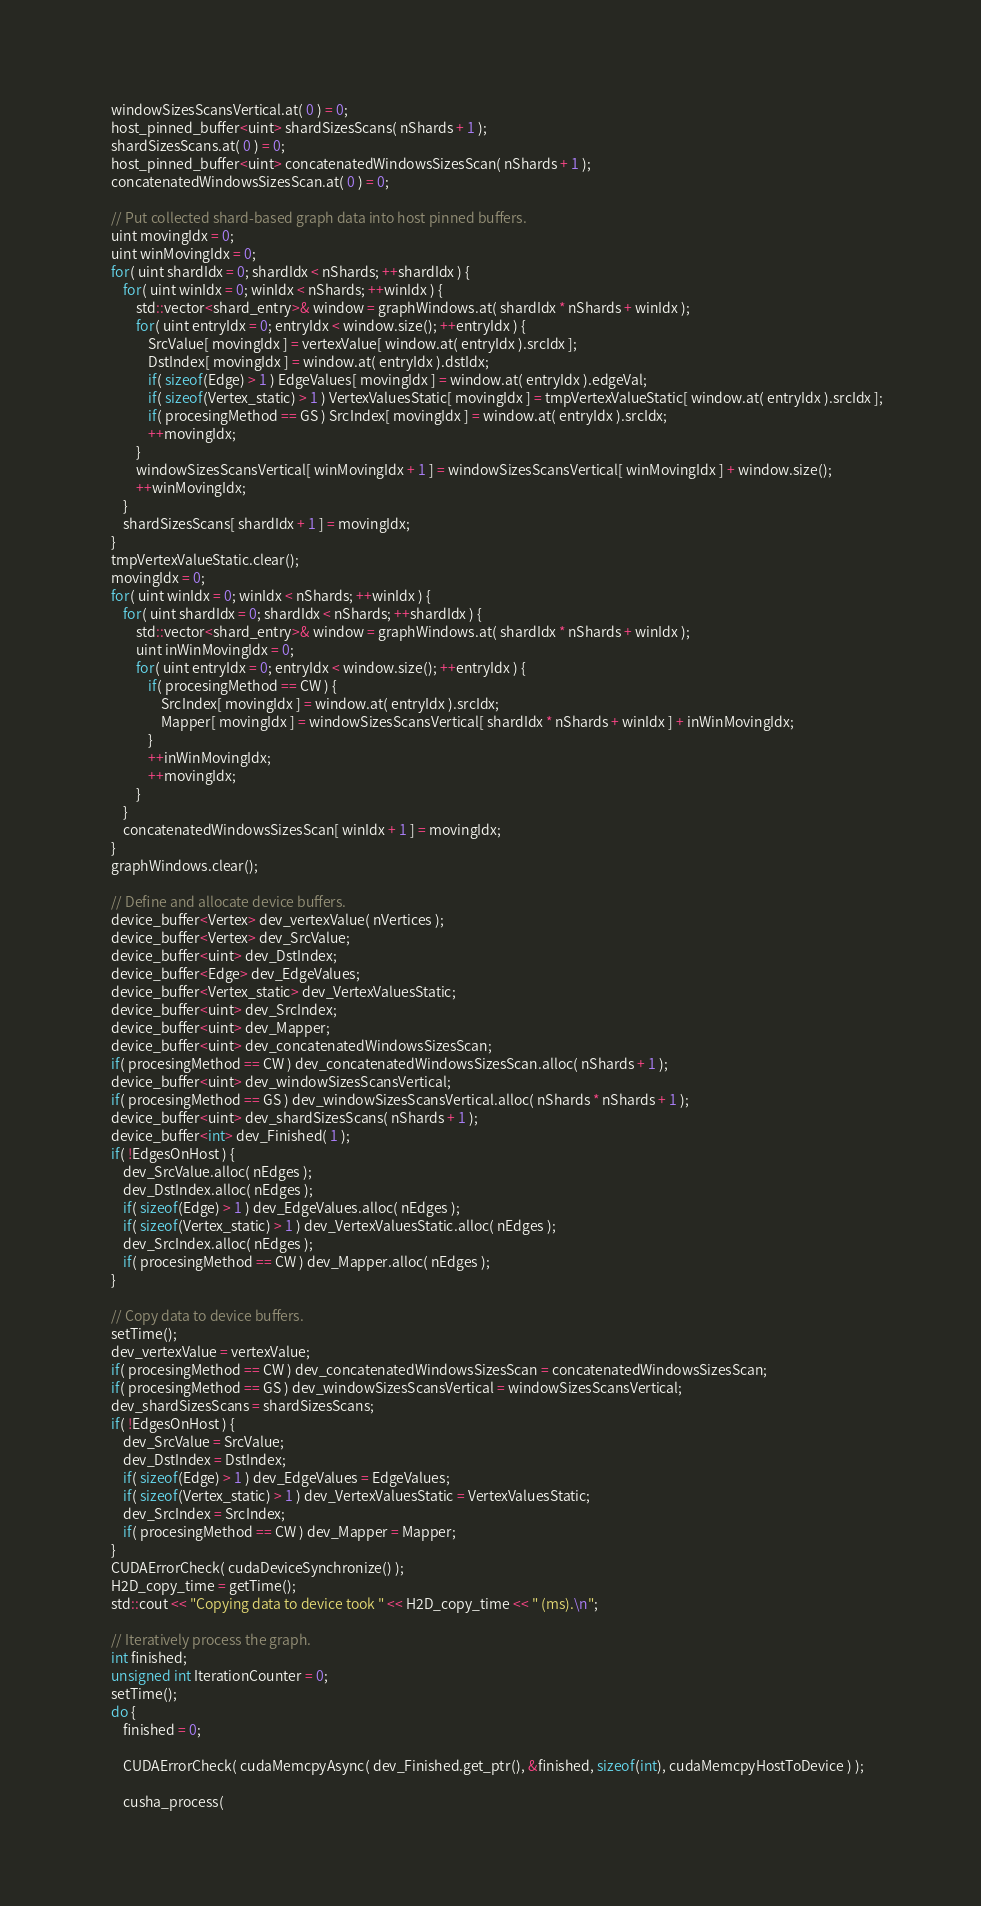<code> <loc_0><loc_0><loc_500><loc_500><_Cuda_>	windowSizesScansVertical.at( 0 ) = 0;
	host_pinned_buffer<uint> shardSizesScans( nShards + 1 );
	shardSizesScans.at( 0 ) = 0;
	host_pinned_buffer<uint> concatenatedWindowsSizesScan( nShards + 1 );
	concatenatedWindowsSizesScan.at( 0 ) = 0;

	// Put collected shard-based graph data into host pinned buffers.
	uint movingIdx = 0;
	uint winMovingIdx = 0;
	for( uint shardIdx = 0; shardIdx < nShards; ++shardIdx ) {
		for( uint winIdx = 0; winIdx < nShards; ++winIdx ) {
			std::vector<shard_entry>& window = graphWindows.at( shardIdx * nShards + winIdx );
			for( uint entryIdx = 0; entryIdx < window.size(); ++entryIdx ) {
				SrcValue[ movingIdx ] = vertexValue[ window.at( entryIdx ).srcIdx ];
				DstIndex[ movingIdx ] = window.at( entryIdx ).dstIdx;
				if( sizeof(Edge) > 1 ) EdgeValues[ movingIdx ] = window.at( entryIdx ).edgeVal;
				if( sizeof(Vertex_static) > 1 ) VertexValuesStatic[ movingIdx ] = tmpVertexValueStatic[ window.at( entryIdx ).srcIdx ];
				if( procesingMethod == GS ) SrcIndex[ movingIdx ] = window.at( entryIdx ).srcIdx;
				++movingIdx;
			}
			windowSizesScansVertical[ winMovingIdx + 1 ] = windowSizesScansVertical[ winMovingIdx ] + window.size();
			++winMovingIdx;
		}
		shardSizesScans[ shardIdx + 1 ] = movingIdx;
	}
	tmpVertexValueStatic.clear();
	movingIdx = 0;
	for( uint winIdx = 0; winIdx < nShards; ++winIdx ) {
		for( uint shardIdx = 0; shardIdx < nShards; ++shardIdx ) {
			std::vector<shard_entry>& window = graphWindows.at( shardIdx * nShards + winIdx );
			uint inWinMovingIdx = 0;
			for( uint entryIdx = 0; entryIdx < window.size(); ++entryIdx ) {
				if( procesingMethod == CW ) {
					SrcIndex[ movingIdx ] = window.at( entryIdx ).srcIdx;
					Mapper[ movingIdx ] = windowSizesScansVertical[ shardIdx * nShards + winIdx ] + inWinMovingIdx;
				}
				++inWinMovingIdx;
				++movingIdx;
			}
		}
		concatenatedWindowsSizesScan[ winIdx + 1 ] = movingIdx;
	}
	graphWindows.clear();

	// Define and allocate device buffers.
	device_buffer<Vertex> dev_vertexValue( nVertices );
	device_buffer<Vertex> dev_SrcValue;
	device_buffer<uint> dev_DstIndex;
	device_buffer<Edge> dev_EdgeValues;
	device_buffer<Vertex_static> dev_VertexValuesStatic;
	device_buffer<uint> dev_SrcIndex;
	device_buffer<uint> dev_Mapper;
	device_buffer<uint> dev_concatenatedWindowsSizesScan;
	if( procesingMethod == CW ) dev_concatenatedWindowsSizesScan.alloc( nShards + 1 );
	device_buffer<uint> dev_windowSizesScansVertical;
	if( procesingMethod == GS ) dev_windowSizesScansVertical.alloc( nShards * nShards + 1 );
	device_buffer<uint> dev_shardSizesScans( nShards + 1 );
	device_buffer<int> dev_Finished( 1 );
	if( !EdgesOnHost ) {
		dev_SrcValue.alloc( nEdges );
		dev_DstIndex.alloc( nEdges );
		if( sizeof(Edge) > 1 ) dev_EdgeValues.alloc( nEdges );
		if( sizeof(Vertex_static) > 1 ) dev_VertexValuesStatic.alloc( nEdges );
		dev_SrcIndex.alloc( nEdges );
		if( procesingMethod == CW ) dev_Mapper.alloc( nEdges );
	}

	// Copy data to device buffers.
	setTime();
	dev_vertexValue = vertexValue;
	if( procesingMethod == CW ) dev_concatenatedWindowsSizesScan = concatenatedWindowsSizesScan;
	if( procesingMethod == GS ) dev_windowSizesScansVertical = windowSizesScansVertical;
	dev_shardSizesScans = shardSizesScans;
	if( !EdgesOnHost ) {
		dev_SrcValue = SrcValue;
		dev_DstIndex = DstIndex;
		if( sizeof(Edge) > 1 ) dev_EdgeValues = EdgeValues;
		if( sizeof(Vertex_static) > 1 ) dev_VertexValuesStatic = VertexValuesStatic;
		dev_SrcIndex = SrcIndex;
		if( procesingMethod == CW ) dev_Mapper = Mapper;
	}
	CUDAErrorCheck( cudaDeviceSynchronize() );
	H2D_copy_time = getTime();
	std::cout << "Copying data to device took " << H2D_copy_time << " (ms).\n";

	// Iteratively process the graph.
	int finished;
	unsigned int IterationCounter = 0;
	setTime();
	do {
		finished = 0;

		CUDAErrorCheck( cudaMemcpyAsync( dev_Finished.get_ptr(), &finished, sizeof(int), cudaMemcpyHostToDevice ) );

		cusha_process(</code> 